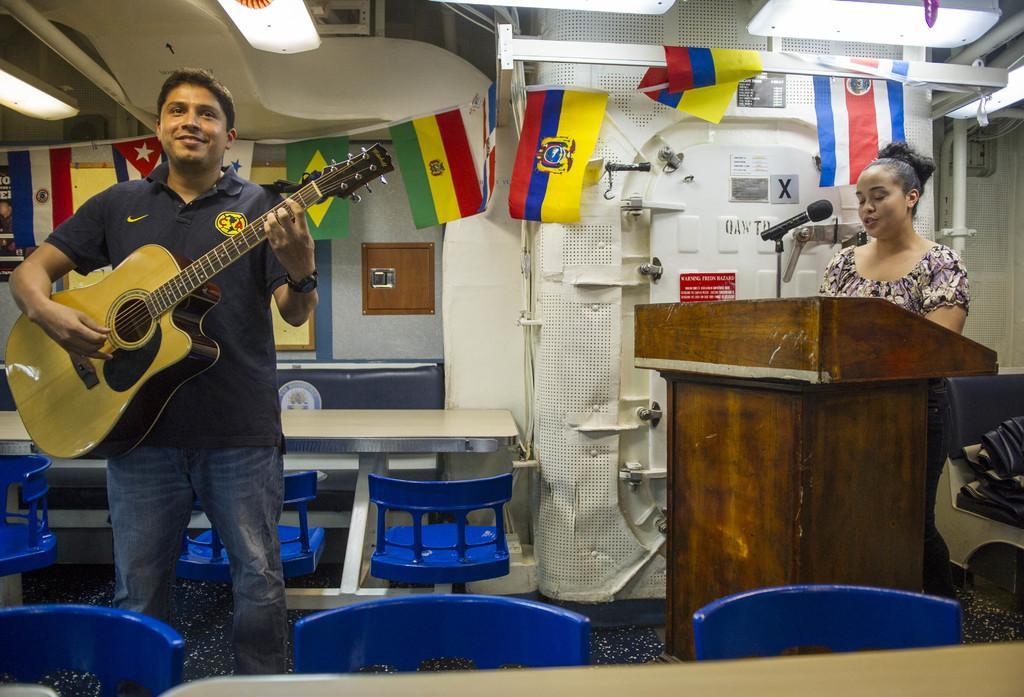Please provide a concise description of this image. The picture is taken inside a room and at the right corner one woman is standing in front of the podium and in the left corner one man is standing wearing blue shirt and playing a guitar and behind him there is one table with chairs and a wall and there are flags inside a room. 